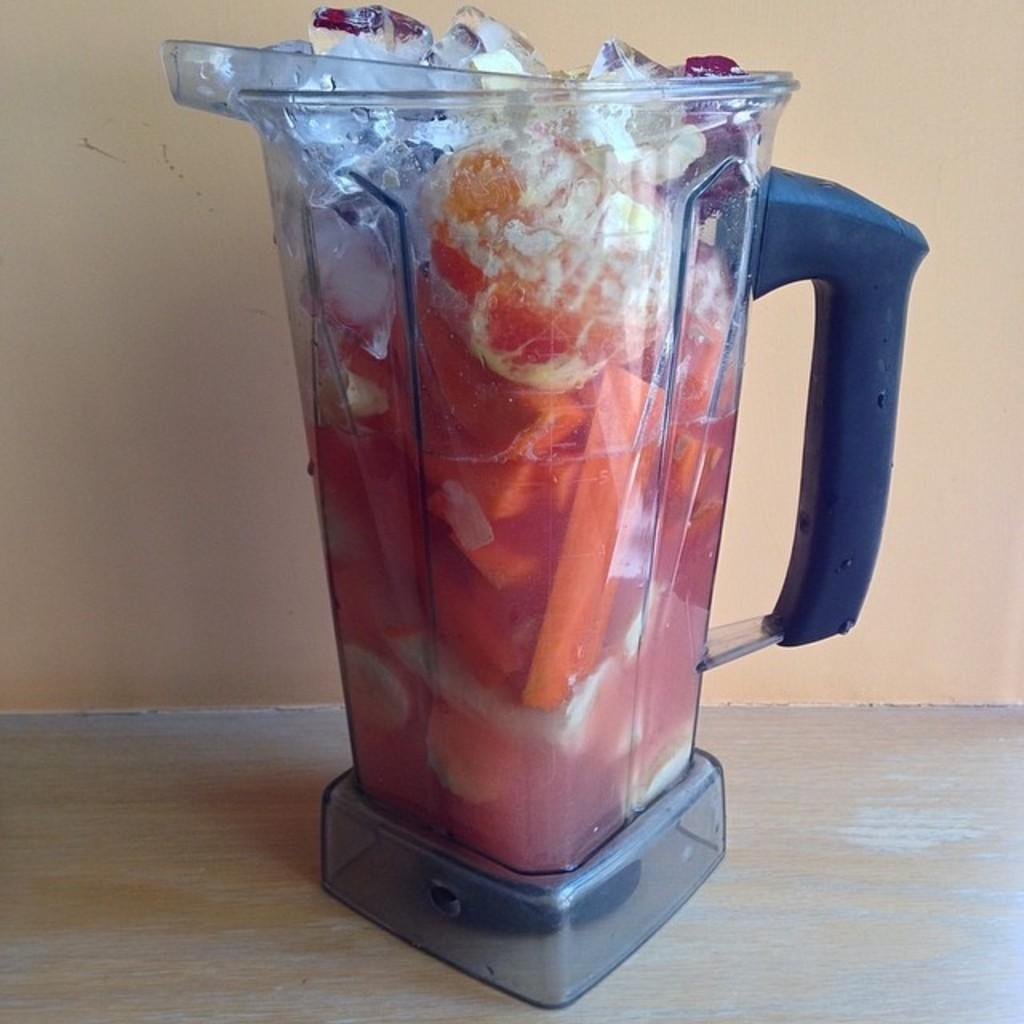What is in the jar that is visible in the image? The jar contains fruits. Are there any additional items in the jar besides the fruits? Yes, ice cubes are placed in the jar. What is the color of the surface on which the jar is placed? The jar is placed on a cream-colored surface. What can be seen in the background of the image? There is a wall in the background of the image. How many prisoners are visible in the image? There are no prisoners or jail in the image; it features a jar with fruits and ice cubes on a cream-colored surface with a wall in the background. 